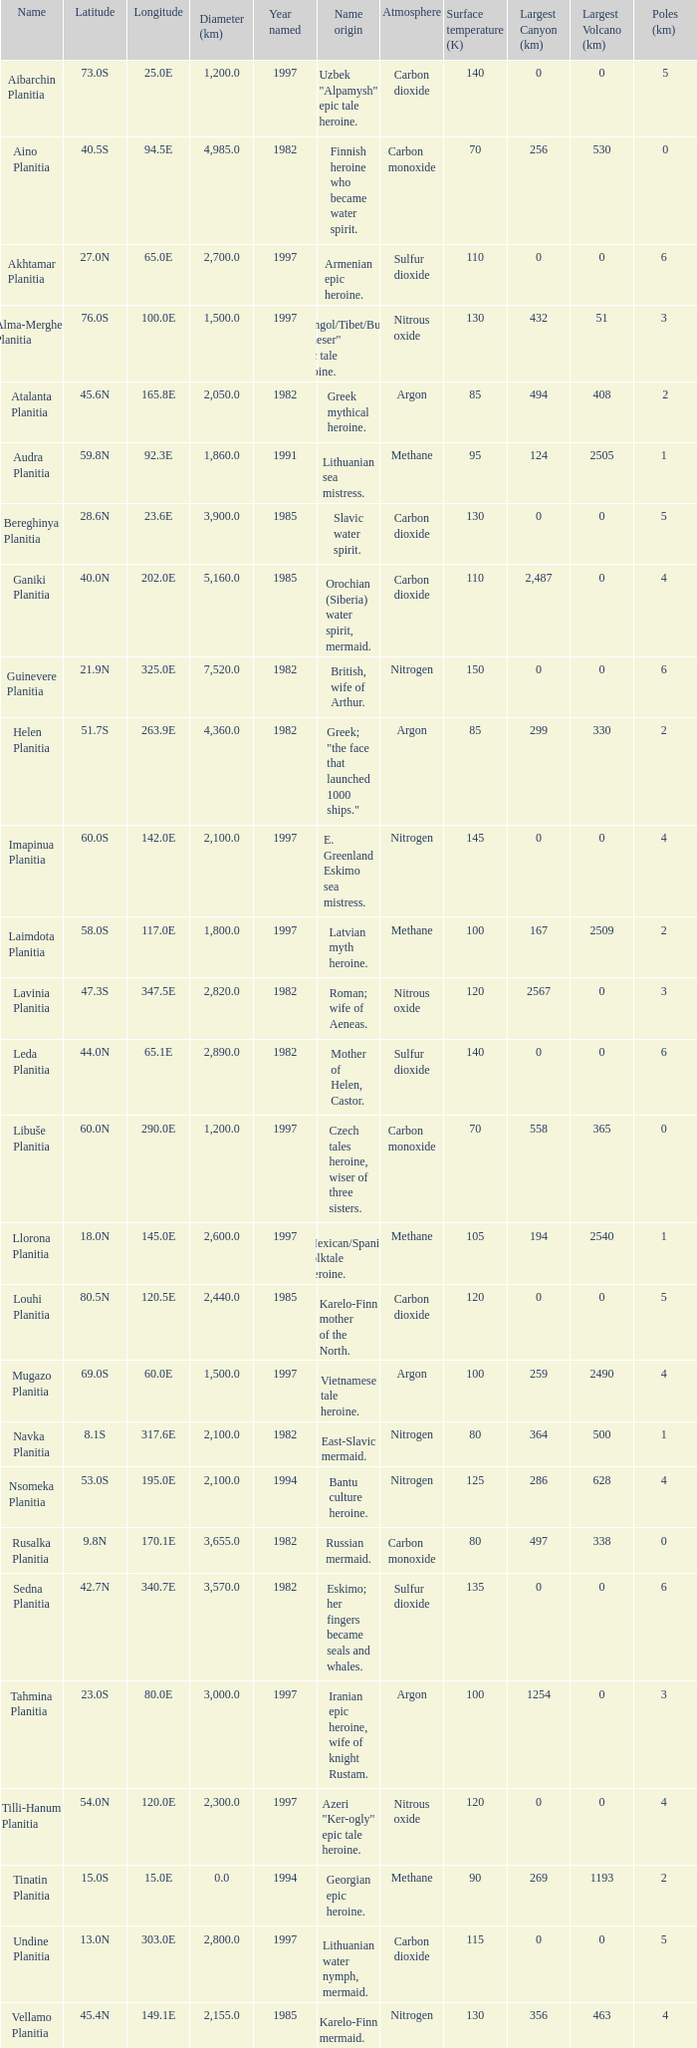What's the name origin of feature of diameter (km) 2,155.0 Karelo-Finn mermaid. 